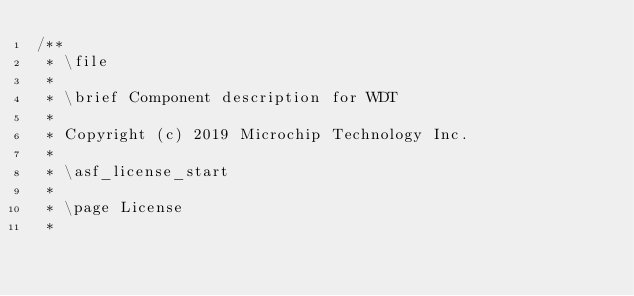Convert code to text. <code><loc_0><loc_0><loc_500><loc_500><_C_>/**
 * \file
 *
 * \brief Component description for WDT
 *
 * Copyright (c) 2019 Microchip Technology Inc.
 *
 * \asf_license_start
 *
 * \page License
 *</code> 